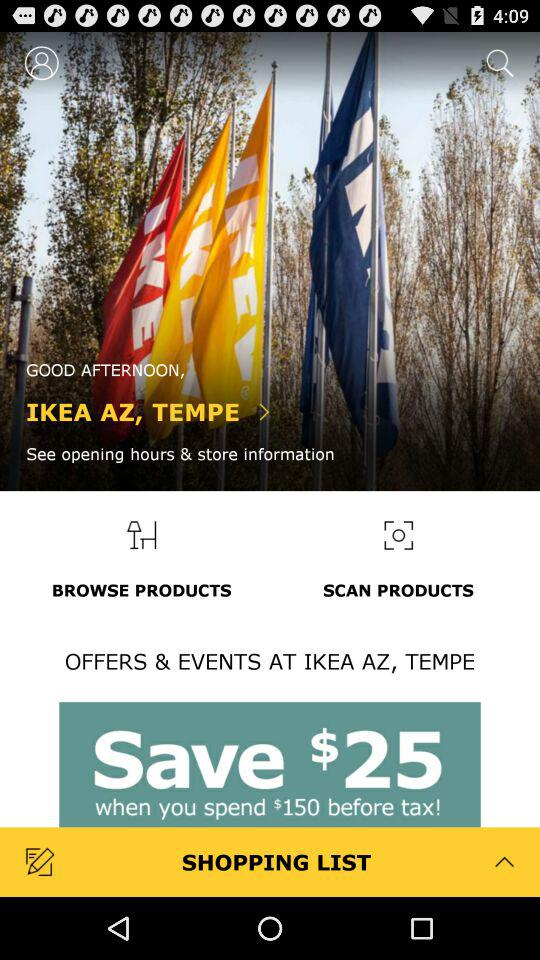How much can we save when we spend $150 before tax? You can save $25 when you spend $150 before tax. 